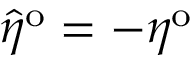Convert formula to latex. <formula><loc_0><loc_0><loc_500><loc_500>\hat { \eta } ^ { o } = - \eta ^ { o }</formula> 